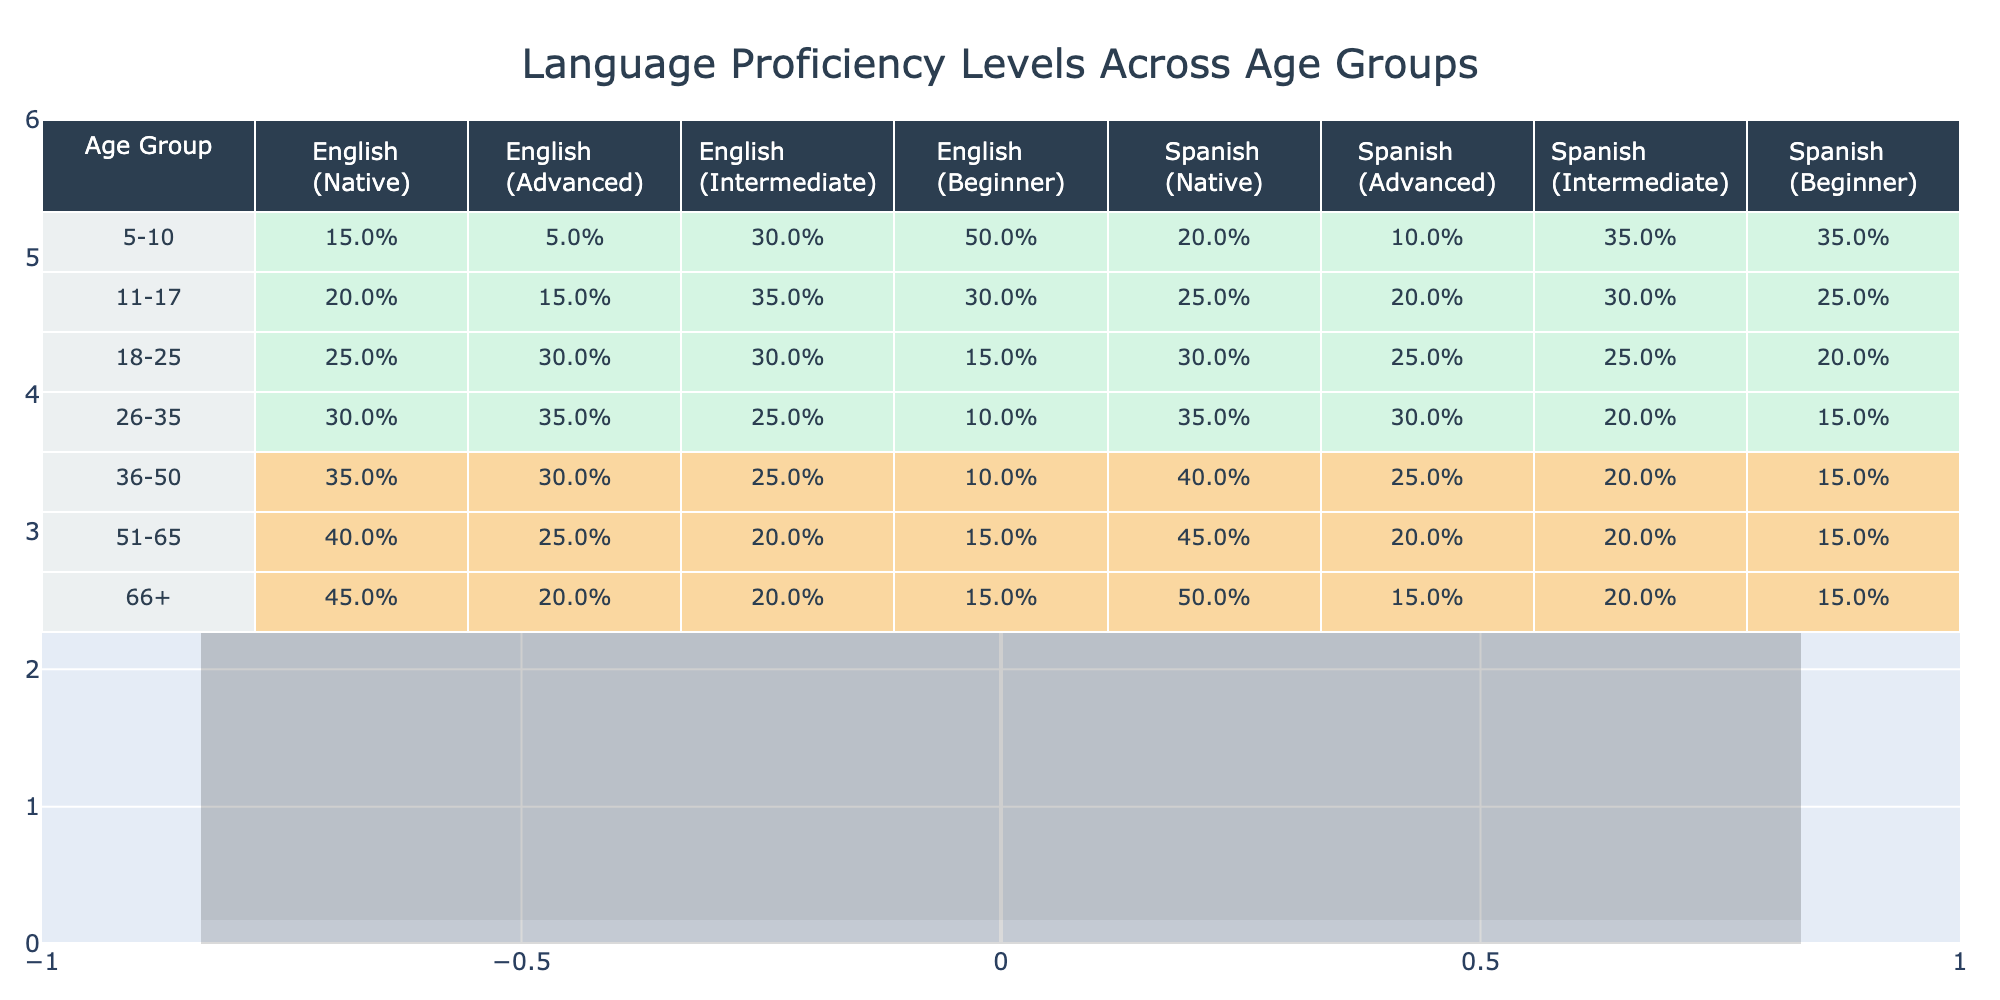What age group has the highest percentage of English native speakers? Looking at the data, the age group 66+ has the highest percentage of English native speakers at 45%.
Answer: 66+ What is the percentage of Spanish beginners in the 18-25 age group? The table shows that in the 18-25 age group, 20% are Spanish beginners.
Answer: 20% Which age group has the lowest percentage of English advanced speakers? The 51-65 age group has the lowest percentage of English advanced speakers at 25%.
Answer: 51-65 What is the difference in percentage of English intermediate speakers between the 26-35 and 36-50 age groups? For 26-35, it is 25%, and for 36-50, it is 25%. The difference is 25% - 25% = 0%.
Answer: 0% What percentage of the 5-10 age group are English beginners? According to the table, 50% of the 5-10 age group are English beginners.
Answer: 50% Is the percentage of Spanish native speakers increasing or decreasing with age? To determine this, we look at the percentages: they increase from 20% (5-10) to 50% (66+), indicating an increase with age.
Answer: Increasing What age group has the highest total percentage of Spanish proficiency (all levels combined)? Adding the percentages for all Spanish proficiency levels in each age group shows that the 36-50 age group has the highest total of 100% (40% native + 25% advanced + 20% intermediate + 15% beginner).
Answer: 36-50 What is the average percentage of English advanced speakers across all age groups? The percentages of English advanced speakers for each age group are 5%, 15%, 30%, 35%, 30%, 25%, and 20%. Summing these gives 5 + 15 + 30 + 35 + 30 + 25 + 20 = 130%. Dividing by 7 age groups gives an average of 130% / 7 = 18.57%.
Answer: 18.57% How does the percentage of English native speakers in the 11-17 age group compare to that of the 51-65 age group? In the 11-17 age group, the percentage is 20%, while in the 51-65 age group, it is 40%. Therefore, 40% - 20% = 20% indicates that the 51-65 group has a higher proportion.
Answer: Higher by 20% What is the median percentage of Spanish advanced speakers across all age groups? Listing the percentages of Spanish advanced speakers by age group: 10%, 20%, 25%, 30%, 30%, 20%, 15%. Ordering these gives: 10%, 15%, 20%, 20%, 25%, 30%, 30%. The median is the middle value, which is 20%.
Answer: 20% 